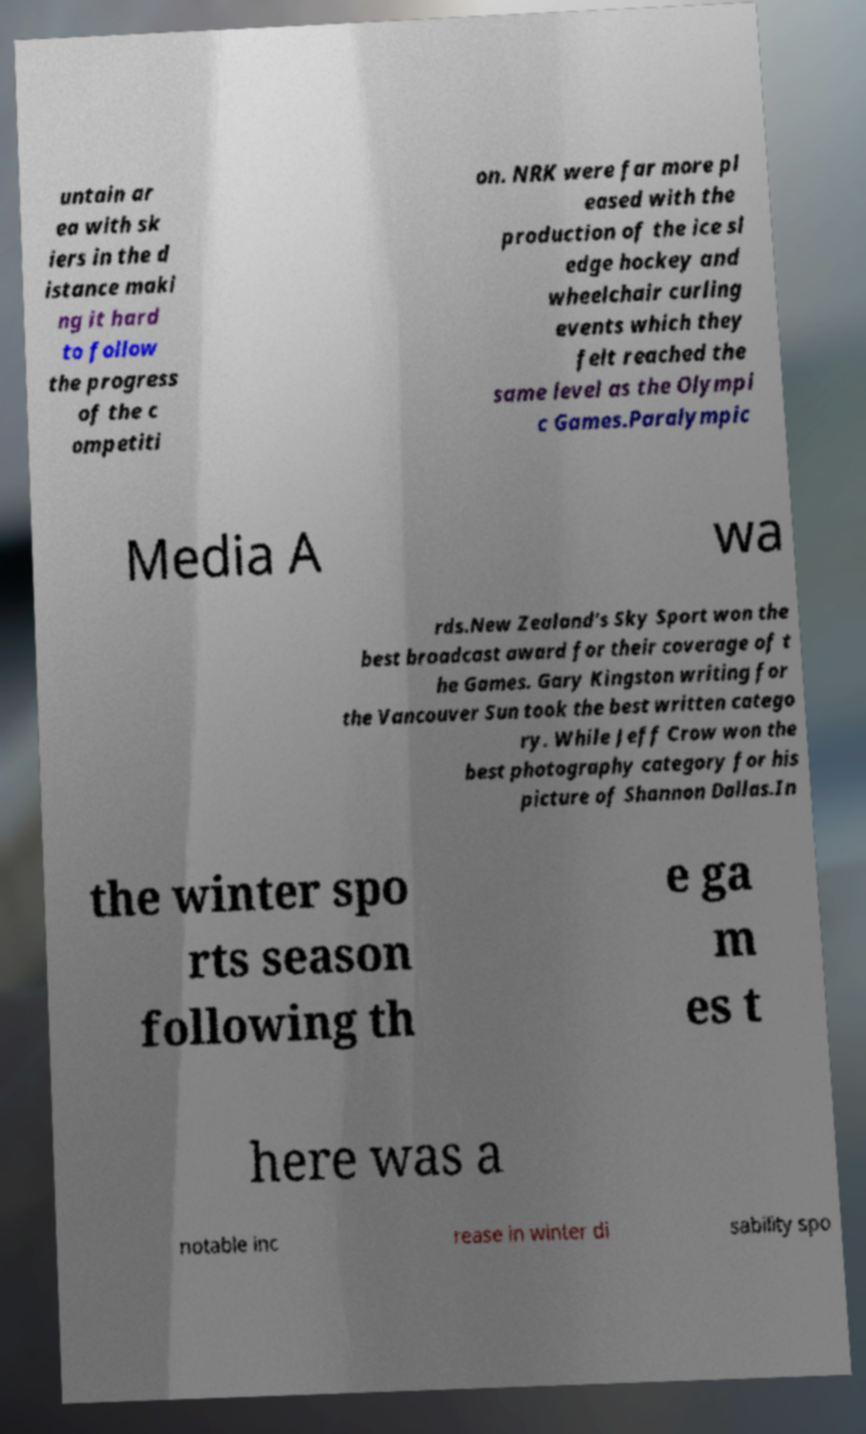Could you assist in decoding the text presented in this image and type it out clearly? untain ar ea with sk iers in the d istance maki ng it hard to follow the progress of the c ompetiti on. NRK were far more pl eased with the production of the ice sl edge hockey and wheelchair curling events which they felt reached the same level as the Olympi c Games.Paralympic Media A wa rds.New Zealand's Sky Sport won the best broadcast award for their coverage of t he Games. Gary Kingston writing for the Vancouver Sun took the best written catego ry. While Jeff Crow won the best photography category for his picture of Shannon Dallas.In the winter spo rts season following th e ga m es t here was a notable inc rease in winter di sability spo 